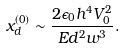<formula> <loc_0><loc_0><loc_500><loc_500>x _ { d } ^ { ( 0 ) } \sim \frac { 2 \epsilon _ { 0 } h ^ { 4 } V _ { 0 } ^ { 2 } } { E d ^ { 2 } w ^ { 3 } } .</formula> 